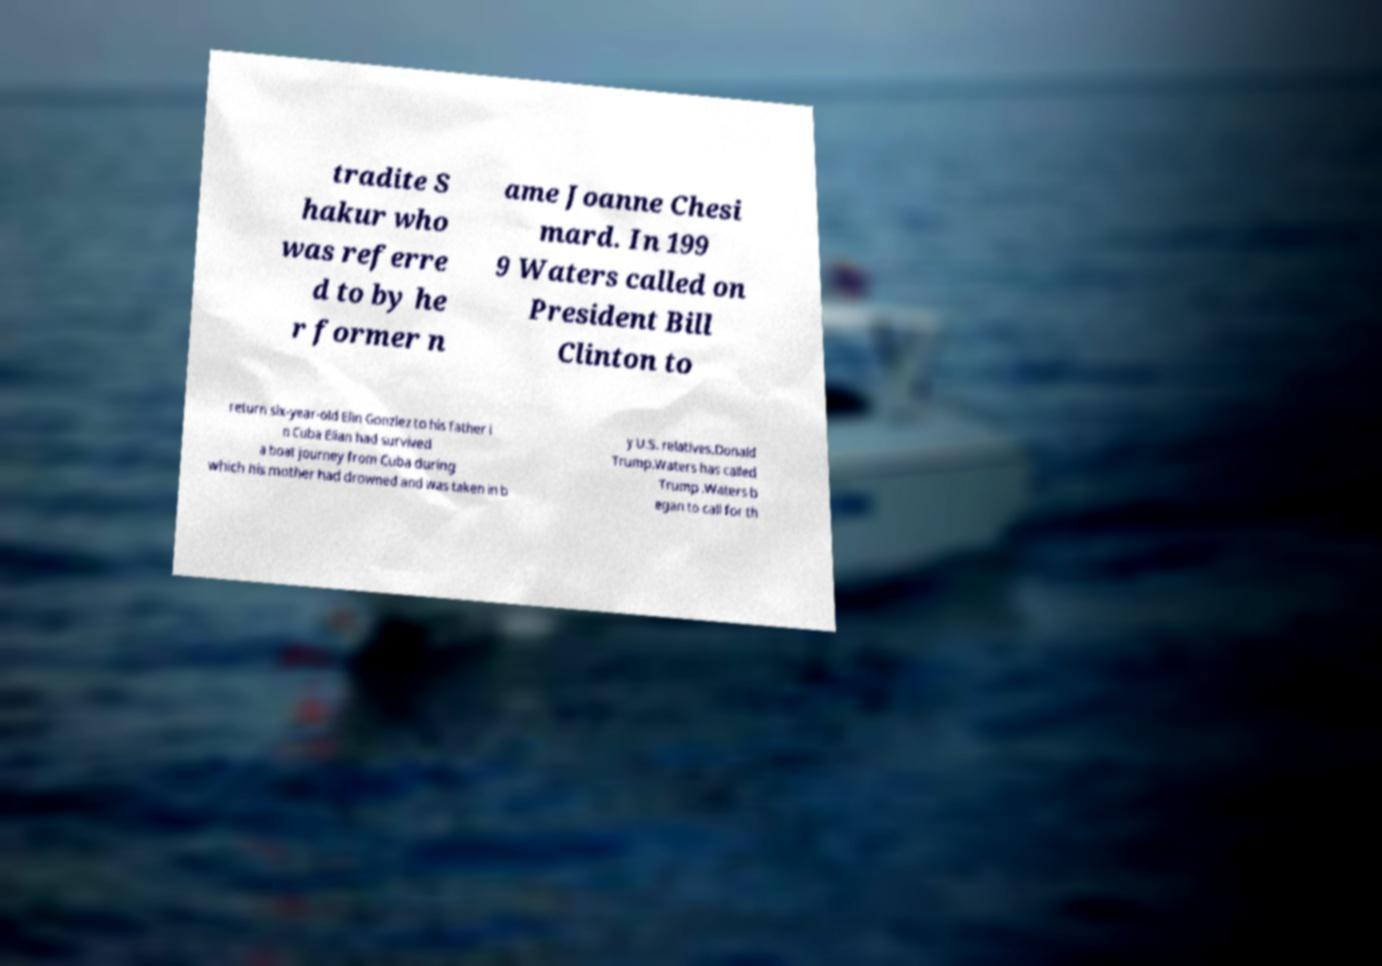What messages or text are displayed in this image? I need them in a readable, typed format. tradite S hakur who was referre d to by he r former n ame Joanne Chesi mard. In 199 9 Waters called on President Bill Clinton to return six-year-old Elin Gonzlez to his father i n Cuba Elian had survived a boat journey from Cuba during which his mother had drowned and was taken in b y U.S. relatives.Donald Trump.Waters has called Trump .Waters b egan to call for th 